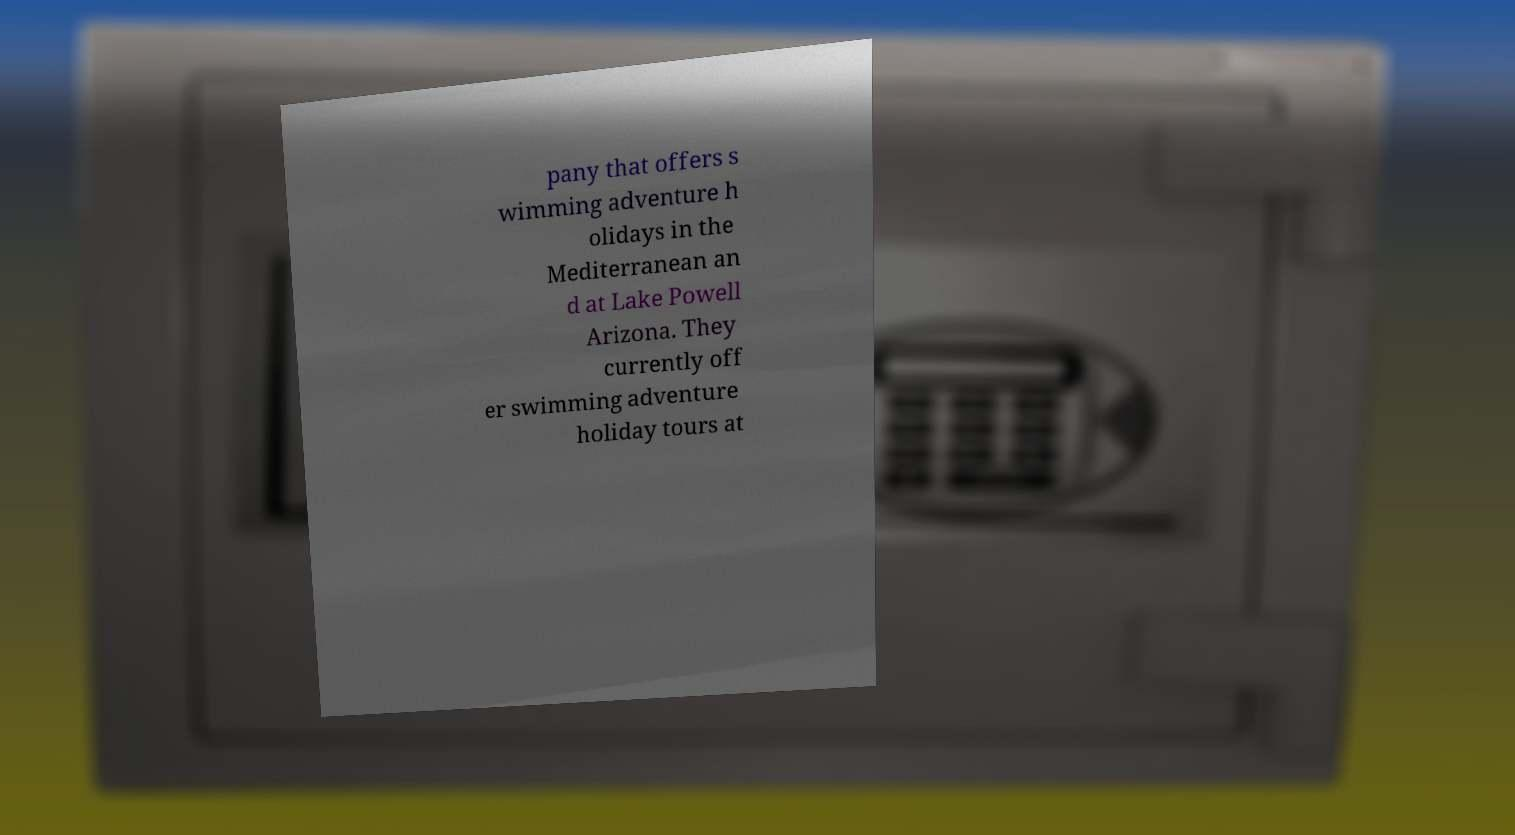For documentation purposes, I need the text within this image transcribed. Could you provide that? pany that offers s wimming adventure h olidays in the Mediterranean an d at Lake Powell Arizona. They currently off er swimming adventure holiday tours at 